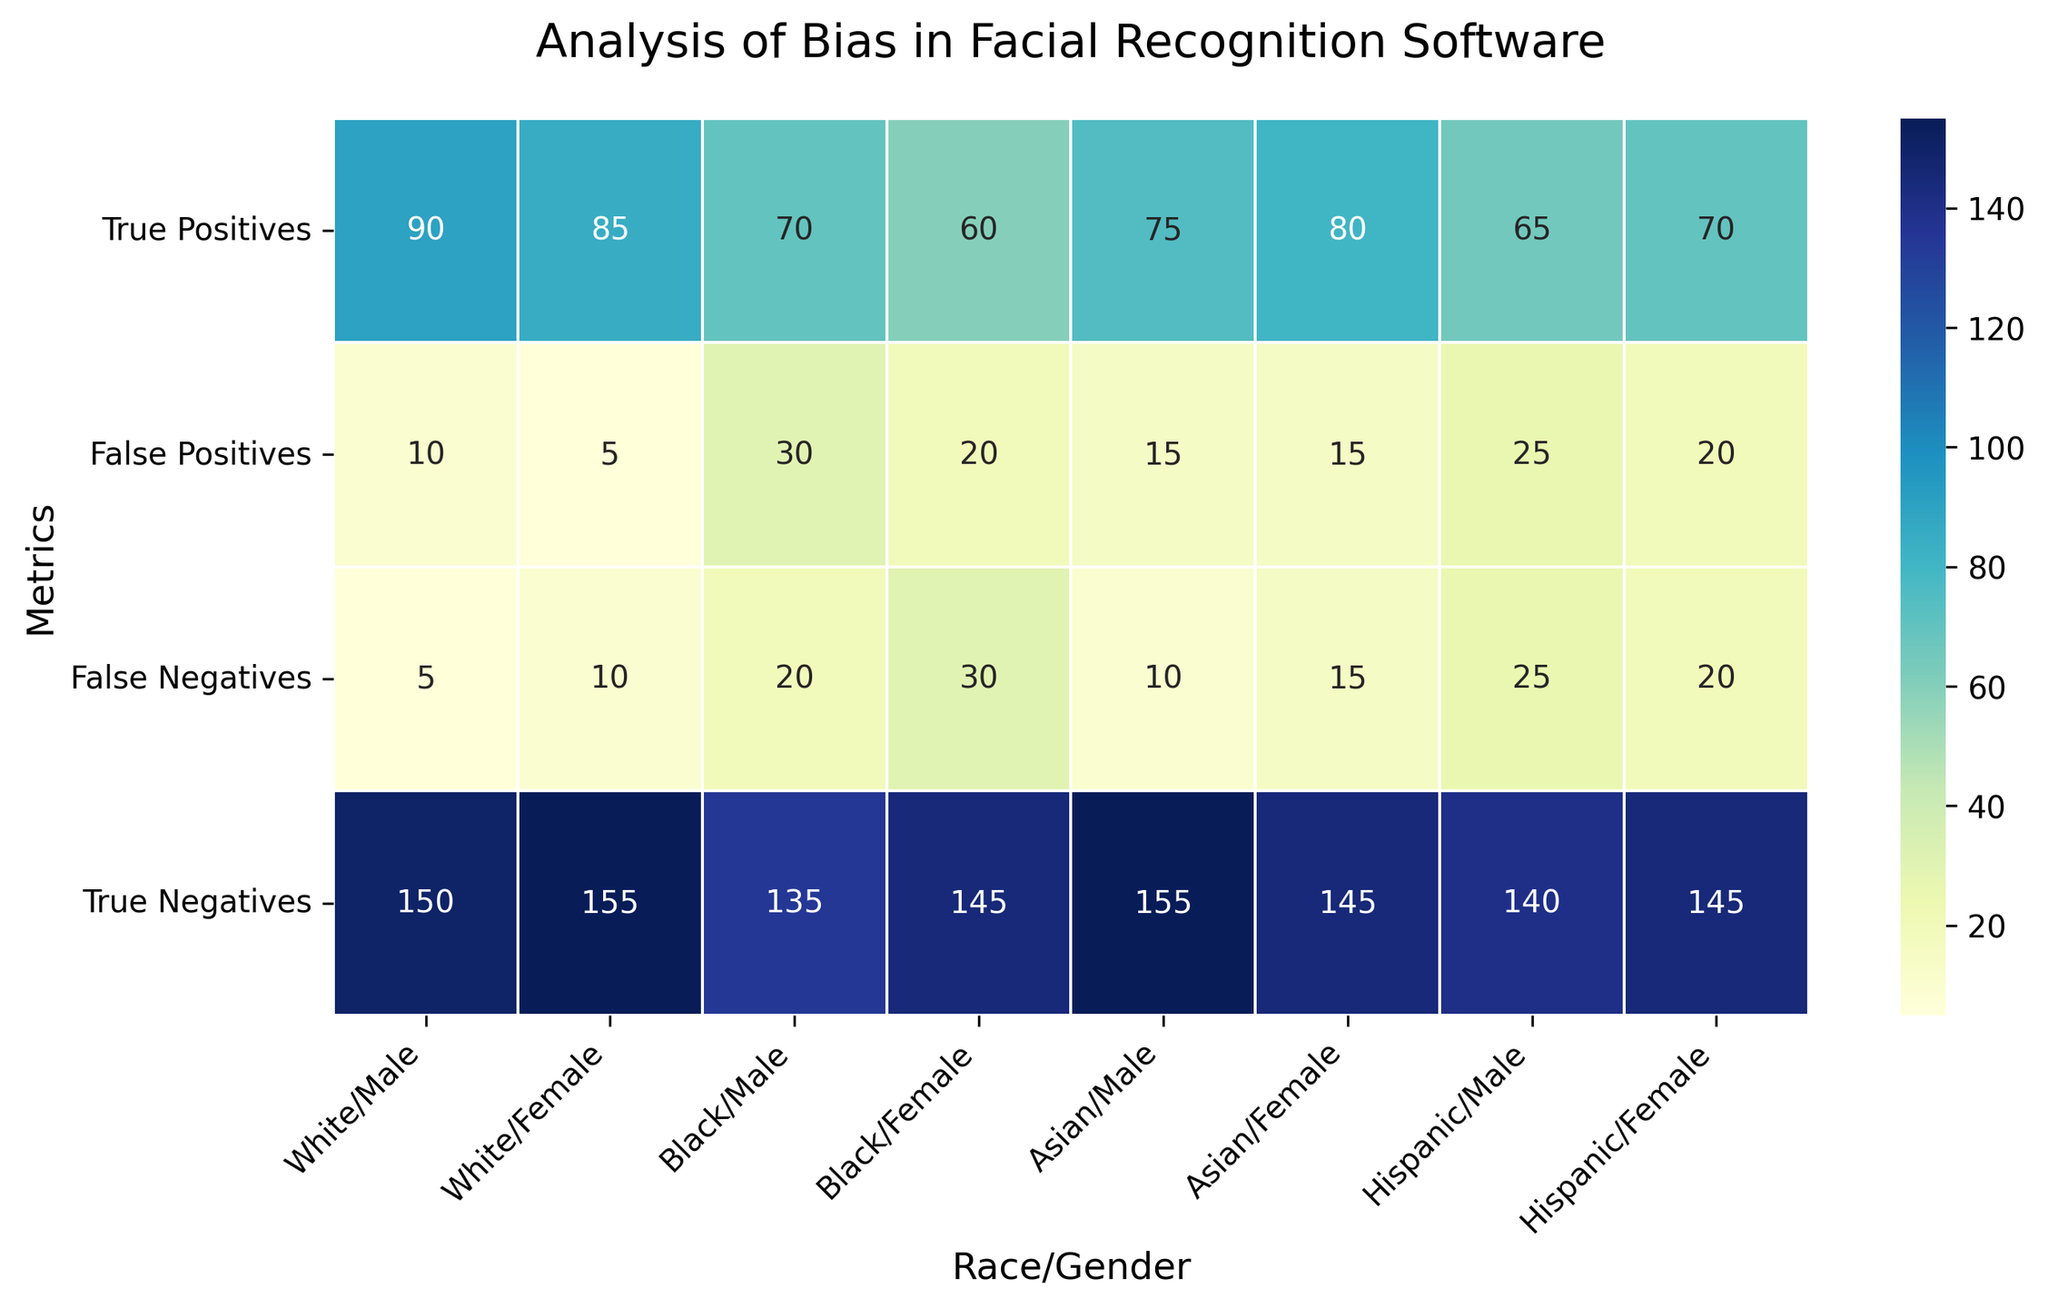What is the total number of false positives across all groups? Sum the values in the 'False Positives' row: 10 (White/Male) + 5 (White/Female) + 30 (Black/Male) + 20 (Black/Female) + 15 (Asian/Male) + 15 (Asian/Female) + 25 (Hispanic/Male) + 20 (Hispanic/Female). Therefore, the total is 140.
Answer: 140 Which group has the highest number of true positives? The highest number in the 'True Positives' row is 90 (White/Male).
Answer: White/Male Are there more false negatives for Black/Females or Asian/Females? Compare the 'False Negatives' for Black/Female (30) and Asian/Female (15). 30 is greater than 15.
Answer: Black/Female How many more true negatives do White/Females have compared to Hispanic/Males? Subtract the true negatives of Hispanic/Males (140) from the true negatives of White/Females (155). Therefore, 155 - 140 = 15.
Answer: 15 Which group has the least number of true positives? The group with the lowest number in the 'True Positives' row is Hispanic/Males (65).
Answer: Hispanic/Male What is the average number of true positives for Asian/Males and Asian/Females? Add the true positives for Asian/Male (75) and Asian/Female (80) and then divide by 2. (75 + 80) / 2 = 77.5
Answer: 77.5 Compare the number of false positives for Black/Males and Hispanic/Females. Are they equal? Compare the value of false positives for Black/Males (30) and Hispanic/Females (20). They are not equal as 30 is not equal to 20.
Answer: No What color on the heatmap would likely represent the highest values? The color indicating the highest values will be the darkest shade in the 'YlGnBu' color palette used in the heatmap. Usually, the highest concentration of YlGnBu is dark blue.
Answer: Dark Blue Calculate the difference in false negatives between the groups with the highest and lowest false negatives. The highest number of false negatives is 30 (for Black/Female), and the lowest number of false negatives is 5 (for White/Male). 30 - 5 = 25.
Answer: 25 What's the combined total of true positives for White/Males and White/Females? Add the true positives for White/Male (90) and White/Female (85). Therefore, 90 + 85 = 175.
Answer: 175 